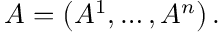<formula> <loc_0><loc_0><loc_500><loc_500>A = \left ( A ^ { 1 } , \dots , A ^ { n } \right ) .</formula> 